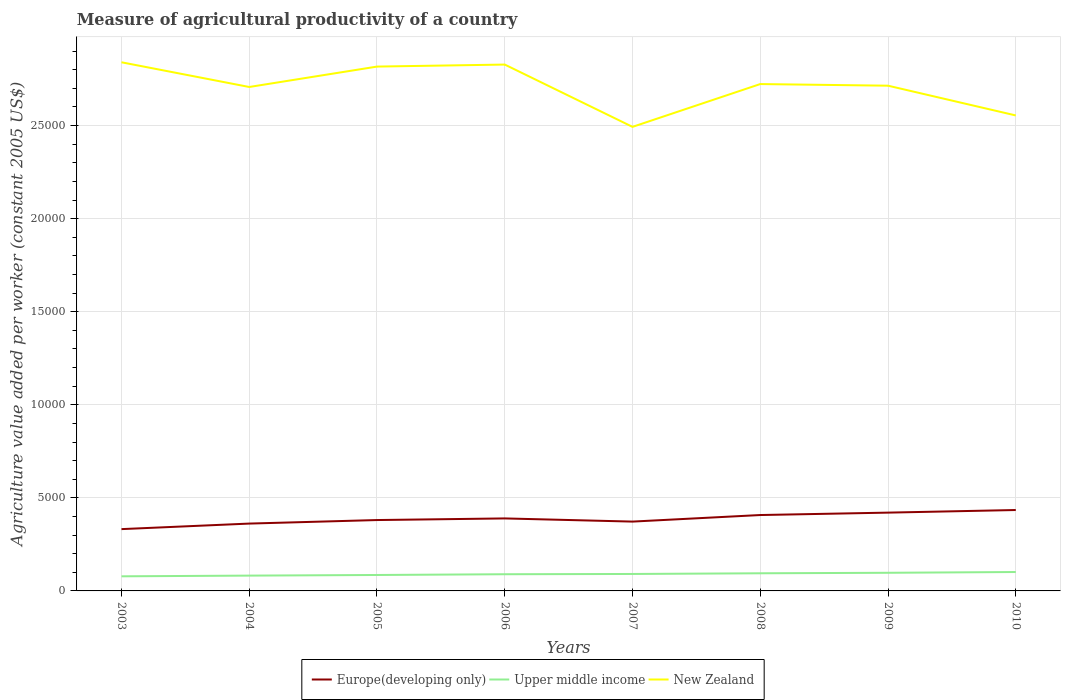How many different coloured lines are there?
Your response must be concise. 3. Across all years, what is the maximum measure of agricultural productivity in Europe(developing only)?
Your response must be concise. 3320.13. What is the total measure of agricultural productivity in New Zealand in the graph?
Give a very brief answer. -1096.03. What is the difference between the highest and the second highest measure of agricultural productivity in Upper middle income?
Your answer should be compact. 231.13. Is the measure of agricultural productivity in New Zealand strictly greater than the measure of agricultural productivity in Upper middle income over the years?
Make the answer very short. No. How many years are there in the graph?
Ensure brevity in your answer.  8. What is the difference between two consecutive major ticks on the Y-axis?
Make the answer very short. 5000. What is the title of the graph?
Ensure brevity in your answer.  Measure of agricultural productivity of a country. Does "Gabon" appear as one of the legend labels in the graph?
Provide a short and direct response. No. What is the label or title of the Y-axis?
Keep it short and to the point. Agriculture value added per worker (constant 2005 US$). What is the Agriculture value added per worker (constant 2005 US$) in Europe(developing only) in 2003?
Your answer should be very brief. 3320.13. What is the Agriculture value added per worker (constant 2005 US$) of Upper middle income in 2003?
Provide a short and direct response. 784.7. What is the Agriculture value added per worker (constant 2005 US$) in New Zealand in 2003?
Your answer should be compact. 2.84e+04. What is the Agriculture value added per worker (constant 2005 US$) of Europe(developing only) in 2004?
Provide a short and direct response. 3617.49. What is the Agriculture value added per worker (constant 2005 US$) of Upper middle income in 2004?
Your answer should be compact. 822.73. What is the Agriculture value added per worker (constant 2005 US$) of New Zealand in 2004?
Your answer should be compact. 2.71e+04. What is the Agriculture value added per worker (constant 2005 US$) of Europe(developing only) in 2005?
Keep it short and to the point. 3807.13. What is the Agriculture value added per worker (constant 2005 US$) in Upper middle income in 2005?
Offer a very short reply. 856.05. What is the Agriculture value added per worker (constant 2005 US$) in New Zealand in 2005?
Your answer should be very brief. 2.82e+04. What is the Agriculture value added per worker (constant 2005 US$) of Europe(developing only) in 2006?
Provide a succinct answer. 3894.52. What is the Agriculture value added per worker (constant 2005 US$) in Upper middle income in 2006?
Keep it short and to the point. 896.2. What is the Agriculture value added per worker (constant 2005 US$) of New Zealand in 2006?
Your answer should be compact. 2.83e+04. What is the Agriculture value added per worker (constant 2005 US$) in Europe(developing only) in 2007?
Give a very brief answer. 3724.44. What is the Agriculture value added per worker (constant 2005 US$) in Upper middle income in 2007?
Make the answer very short. 910.43. What is the Agriculture value added per worker (constant 2005 US$) in New Zealand in 2007?
Ensure brevity in your answer.  2.49e+04. What is the Agriculture value added per worker (constant 2005 US$) of Europe(developing only) in 2008?
Your answer should be compact. 4077.1. What is the Agriculture value added per worker (constant 2005 US$) of Upper middle income in 2008?
Offer a terse response. 947.85. What is the Agriculture value added per worker (constant 2005 US$) in New Zealand in 2008?
Give a very brief answer. 2.72e+04. What is the Agriculture value added per worker (constant 2005 US$) in Europe(developing only) in 2009?
Your response must be concise. 4205.82. What is the Agriculture value added per worker (constant 2005 US$) in Upper middle income in 2009?
Ensure brevity in your answer.  974.73. What is the Agriculture value added per worker (constant 2005 US$) of New Zealand in 2009?
Provide a short and direct response. 2.71e+04. What is the Agriculture value added per worker (constant 2005 US$) of Europe(developing only) in 2010?
Provide a short and direct response. 4346.2. What is the Agriculture value added per worker (constant 2005 US$) in Upper middle income in 2010?
Your response must be concise. 1015.83. What is the Agriculture value added per worker (constant 2005 US$) in New Zealand in 2010?
Offer a terse response. 2.55e+04. Across all years, what is the maximum Agriculture value added per worker (constant 2005 US$) in Europe(developing only)?
Provide a succinct answer. 4346.2. Across all years, what is the maximum Agriculture value added per worker (constant 2005 US$) in Upper middle income?
Offer a very short reply. 1015.83. Across all years, what is the maximum Agriculture value added per worker (constant 2005 US$) of New Zealand?
Your answer should be compact. 2.84e+04. Across all years, what is the minimum Agriculture value added per worker (constant 2005 US$) of Europe(developing only)?
Provide a succinct answer. 3320.13. Across all years, what is the minimum Agriculture value added per worker (constant 2005 US$) of Upper middle income?
Keep it short and to the point. 784.7. Across all years, what is the minimum Agriculture value added per worker (constant 2005 US$) in New Zealand?
Give a very brief answer. 2.49e+04. What is the total Agriculture value added per worker (constant 2005 US$) of Europe(developing only) in the graph?
Give a very brief answer. 3.10e+04. What is the total Agriculture value added per worker (constant 2005 US$) in Upper middle income in the graph?
Make the answer very short. 7208.51. What is the total Agriculture value added per worker (constant 2005 US$) of New Zealand in the graph?
Give a very brief answer. 2.17e+05. What is the difference between the Agriculture value added per worker (constant 2005 US$) of Europe(developing only) in 2003 and that in 2004?
Offer a very short reply. -297.36. What is the difference between the Agriculture value added per worker (constant 2005 US$) of Upper middle income in 2003 and that in 2004?
Your response must be concise. -38.03. What is the difference between the Agriculture value added per worker (constant 2005 US$) of New Zealand in 2003 and that in 2004?
Give a very brief answer. 1327.48. What is the difference between the Agriculture value added per worker (constant 2005 US$) of Europe(developing only) in 2003 and that in 2005?
Give a very brief answer. -487. What is the difference between the Agriculture value added per worker (constant 2005 US$) in Upper middle income in 2003 and that in 2005?
Your answer should be very brief. -71.35. What is the difference between the Agriculture value added per worker (constant 2005 US$) of New Zealand in 2003 and that in 2005?
Give a very brief answer. 231.46. What is the difference between the Agriculture value added per worker (constant 2005 US$) of Europe(developing only) in 2003 and that in 2006?
Ensure brevity in your answer.  -574.4. What is the difference between the Agriculture value added per worker (constant 2005 US$) of Upper middle income in 2003 and that in 2006?
Offer a very short reply. -111.5. What is the difference between the Agriculture value added per worker (constant 2005 US$) in New Zealand in 2003 and that in 2006?
Offer a very short reply. 122.47. What is the difference between the Agriculture value added per worker (constant 2005 US$) in Europe(developing only) in 2003 and that in 2007?
Provide a succinct answer. -404.32. What is the difference between the Agriculture value added per worker (constant 2005 US$) in Upper middle income in 2003 and that in 2007?
Your response must be concise. -125.72. What is the difference between the Agriculture value added per worker (constant 2005 US$) in New Zealand in 2003 and that in 2007?
Your response must be concise. 3469.67. What is the difference between the Agriculture value added per worker (constant 2005 US$) of Europe(developing only) in 2003 and that in 2008?
Ensure brevity in your answer.  -756.97. What is the difference between the Agriculture value added per worker (constant 2005 US$) in Upper middle income in 2003 and that in 2008?
Offer a terse response. -163.15. What is the difference between the Agriculture value added per worker (constant 2005 US$) of New Zealand in 2003 and that in 2008?
Offer a terse response. 1169.99. What is the difference between the Agriculture value added per worker (constant 2005 US$) in Europe(developing only) in 2003 and that in 2009?
Ensure brevity in your answer.  -885.69. What is the difference between the Agriculture value added per worker (constant 2005 US$) in Upper middle income in 2003 and that in 2009?
Provide a short and direct response. -190.02. What is the difference between the Agriculture value added per worker (constant 2005 US$) in New Zealand in 2003 and that in 2009?
Keep it short and to the point. 1257.55. What is the difference between the Agriculture value added per worker (constant 2005 US$) in Europe(developing only) in 2003 and that in 2010?
Your answer should be very brief. -1026.08. What is the difference between the Agriculture value added per worker (constant 2005 US$) of Upper middle income in 2003 and that in 2010?
Ensure brevity in your answer.  -231.13. What is the difference between the Agriculture value added per worker (constant 2005 US$) of New Zealand in 2003 and that in 2010?
Your response must be concise. 2855.97. What is the difference between the Agriculture value added per worker (constant 2005 US$) of Europe(developing only) in 2004 and that in 2005?
Your response must be concise. -189.64. What is the difference between the Agriculture value added per worker (constant 2005 US$) of Upper middle income in 2004 and that in 2005?
Make the answer very short. -33.32. What is the difference between the Agriculture value added per worker (constant 2005 US$) in New Zealand in 2004 and that in 2005?
Provide a short and direct response. -1096.03. What is the difference between the Agriculture value added per worker (constant 2005 US$) of Europe(developing only) in 2004 and that in 2006?
Offer a very short reply. -277.04. What is the difference between the Agriculture value added per worker (constant 2005 US$) in Upper middle income in 2004 and that in 2006?
Your answer should be compact. -73.46. What is the difference between the Agriculture value added per worker (constant 2005 US$) in New Zealand in 2004 and that in 2006?
Make the answer very short. -1205.01. What is the difference between the Agriculture value added per worker (constant 2005 US$) of Europe(developing only) in 2004 and that in 2007?
Provide a short and direct response. -106.96. What is the difference between the Agriculture value added per worker (constant 2005 US$) in Upper middle income in 2004 and that in 2007?
Make the answer very short. -87.69. What is the difference between the Agriculture value added per worker (constant 2005 US$) in New Zealand in 2004 and that in 2007?
Keep it short and to the point. 2142.19. What is the difference between the Agriculture value added per worker (constant 2005 US$) in Europe(developing only) in 2004 and that in 2008?
Provide a succinct answer. -459.61. What is the difference between the Agriculture value added per worker (constant 2005 US$) of Upper middle income in 2004 and that in 2008?
Your answer should be compact. -125.12. What is the difference between the Agriculture value added per worker (constant 2005 US$) of New Zealand in 2004 and that in 2008?
Offer a very short reply. -157.49. What is the difference between the Agriculture value added per worker (constant 2005 US$) of Europe(developing only) in 2004 and that in 2009?
Ensure brevity in your answer.  -588.33. What is the difference between the Agriculture value added per worker (constant 2005 US$) of Upper middle income in 2004 and that in 2009?
Give a very brief answer. -151.99. What is the difference between the Agriculture value added per worker (constant 2005 US$) in New Zealand in 2004 and that in 2009?
Your answer should be compact. -69.94. What is the difference between the Agriculture value added per worker (constant 2005 US$) of Europe(developing only) in 2004 and that in 2010?
Your answer should be very brief. -728.72. What is the difference between the Agriculture value added per worker (constant 2005 US$) of Upper middle income in 2004 and that in 2010?
Keep it short and to the point. -193.09. What is the difference between the Agriculture value added per worker (constant 2005 US$) in New Zealand in 2004 and that in 2010?
Your answer should be very brief. 1528.49. What is the difference between the Agriculture value added per worker (constant 2005 US$) of Europe(developing only) in 2005 and that in 2006?
Make the answer very short. -87.4. What is the difference between the Agriculture value added per worker (constant 2005 US$) of Upper middle income in 2005 and that in 2006?
Provide a short and direct response. -40.15. What is the difference between the Agriculture value added per worker (constant 2005 US$) of New Zealand in 2005 and that in 2006?
Make the answer very short. -108.99. What is the difference between the Agriculture value added per worker (constant 2005 US$) of Europe(developing only) in 2005 and that in 2007?
Offer a very short reply. 82.68. What is the difference between the Agriculture value added per worker (constant 2005 US$) in Upper middle income in 2005 and that in 2007?
Give a very brief answer. -54.38. What is the difference between the Agriculture value added per worker (constant 2005 US$) of New Zealand in 2005 and that in 2007?
Your answer should be compact. 3238.21. What is the difference between the Agriculture value added per worker (constant 2005 US$) in Europe(developing only) in 2005 and that in 2008?
Keep it short and to the point. -269.97. What is the difference between the Agriculture value added per worker (constant 2005 US$) of Upper middle income in 2005 and that in 2008?
Provide a succinct answer. -91.8. What is the difference between the Agriculture value added per worker (constant 2005 US$) in New Zealand in 2005 and that in 2008?
Your answer should be compact. 938.53. What is the difference between the Agriculture value added per worker (constant 2005 US$) of Europe(developing only) in 2005 and that in 2009?
Your answer should be compact. -398.69. What is the difference between the Agriculture value added per worker (constant 2005 US$) in Upper middle income in 2005 and that in 2009?
Your response must be concise. -118.68. What is the difference between the Agriculture value added per worker (constant 2005 US$) of New Zealand in 2005 and that in 2009?
Your answer should be compact. 1026.09. What is the difference between the Agriculture value added per worker (constant 2005 US$) in Europe(developing only) in 2005 and that in 2010?
Ensure brevity in your answer.  -539.08. What is the difference between the Agriculture value added per worker (constant 2005 US$) of Upper middle income in 2005 and that in 2010?
Keep it short and to the point. -159.78. What is the difference between the Agriculture value added per worker (constant 2005 US$) of New Zealand in 2005 and that in 2010?
Give a very brief answer. 2624.51. What is the difference between the Agriculture value added per worker (constant 2005 US$) of Europe(developing only) in 2006 and that in 2007?
Offer a terse response. 170.08. What is the difference between the Agriculture value added per worker (constant 2005 US$) in Upper middle income in 2006 and that in 2007?
Ensure brevity in your answer.  -14.23. What is the difference between the Agriculture value added per worker (constant 2005 US$) in New Zealand in 2006 and that in 2007?
Offer a very short reply. 3347.2. What is the difference between the Agriculture value added per worker (constant 2005 US$) of Europe(developing only) in 2006 and that in 2008?
Offer a terse response. -182.58. What is the difference between the Agriculture value added per worker (constant 2005 US$) of Upper middle income in 2006 and that in 2008?
Keep it short and to the point. -51.65. What is the difference between the Agriculture value added per worker (constant 2005 US$) in New Zealand in 2006 and that in 2008?
Provide a short and direct response. 1047.52. What is the difference between the Agriculture value added per worker (constant 2005 US$) in Europe(developing only) in 2006 and that in 2009?
Provide a succinct answer. -311.29. What is the difference between the Agriculture value added per worker (constant 2005 US$) in Upper middle income in 2006 and that in 2009?
Your response must be concise. -78.53. What is the difference between the Agriculture value added per worker (constant 2005 US$) of New Zealand in 2006 and that in 2009?
Your answer should be compact. 1135.08. What is the difference between the Agriculture value added per worker (constant 2005 US$) of Europe(developing only) in 2006 and that in 2010?
Offer a very short reply. -451.68. What is the difference between the Agriculture value added per worker (constant 2005 US$) of Upper middle income in 2006 and that in 2010?
Your answer should be compact. -119.63. What is the difference between the Agriculture value added per worker (constant 2005 US$) of New Zealand in 2006 and that in 2010?
Keep it short and to the point. 2733.5. What is the difference between the Agriculture value added per worker (constant 2005 US$) of Europe(developing only) in 2007 and that in 2008?
Keep it short and to the point. -352.66. What is the difference between the Agriculture value added per worker (constant 2005 US$) in Upper middle income in 2007 and that in 2008?
Your answer should be very brief. -37.42. What is the difference between the Agriculture value added per worker (constant 2005 US$) of New Zealand in 2007 and that in 2008?
Provide a short and direct response. -2299.68. What is the difference between the Agriculture value added per worker (constant 2005 US$) in Europe(developing only) in 2007 and that in 2009?
Give a very brief answer. -481.37. What is the difference between the Agriculture value added per worker (constant 2005 US$) in Upper middle income in 2007 and that in 2009?
Keep it short and to the point. -64.3. What is the difference between the Agriculture value added per worker (constant 2005 US$) in New Zealand in 2007 and that in 2009?
Your answer should be very brief. -2212.12. What is the difference between the Agriculture value added per worker (constant 2005 US$) of Europe(developing only) in 2007 and that in 2010?
Ensure brevity in your answer.  -621.76. What is the difference between the Agriculture value added per worker (constant 2005 US$) of Upper middle income in 2007 and that in 2010?
Offer a very short reply. -105.4. What is the difference between the Agriculture value added per worker (constant 2005 US$) of New Zealand in 2007 and that in 2010?
Your response must be concise. -613.7. What is the difference between the Agriculture value added per worker (constant 2005 US$) of Europe(developing only) in 2008 and that in 2009?
Provide a short and direct response. -128.72. What is the difference between the Agriculture value added per worker (constant 2005 US$) of Upper middle income in 2008 and that in 2009?
Provide a succinct answer. -26.88. What is the difference between the Agriculture value added per worker (constant 2005 US$) of New Zealand in 2008 and that in 2009?
Your answer should be compact. 87.55. What is the difference between the Agriculture value added per worker (constant 2005 US$) in Europe(developing only) in 2008 and that in 2010?
Keep it short and to the point. -269.1. What is the difference between the Agriculture value added per worker (constant 2005 US$) of Upper middle income in 2008 and that in 2010?
Your response must be concise. -67.98. What is the difference between the Agriculture value added per worker (constant 2005 US$) of New Zealand in 2008 and that in 2010?
Your answer should be compact. 1685.98. What is the difference between the Agriculture value added per worker (constant 2005 US$) in Europe(developing only) in 2009 and that in 2010?
Make the answer very short. -140.39. What is the difference between the Agriculture value added per worker (constant 2005 US$) in Upper middle income in 2009 and that in 2010?
Provide a short and direct response. -41.1. What is the difference between the Agriculture value added per worker (constant 2005 US$) in New Zealand in 2009 and that in 2010?
Provide a short and direct response. 1598.42. What is the difference between the Agriculture value added per worker (constant 2005 US$) in Europe(developing only) in 2003 and the Agriculture value added per worker (constant 2005 US$) in Upper middle income in 2004?
Make the answer very short. 2497.4. What is the difference between the Agriculture value added per worker (constant 2005 US$) of Europe(developing only) in 2003 and the Agriculture value added per worker (constant 2005 US$) of New Zealand in 2004?
Provide a succinct answer. -2.38e+04. What is the difference between the Agriculture value added per worker (constant 2005 US$) in Upper middle income in 2003 and the Agriculture value added per worker (constant 2005 US$) in New Zealand in 2004?
Offer a very short reply. -2.63e+04. What is the difference between the Agriculture value added per worker (constant 2005 US$) of Europe(developing only) in 2003 and the Agriculture value added per worker (constant 2005 US$) of Upper middle income in 2005?
Your answer should be very brief. 2464.08. What is the difference between the Agriculture value added per worker (constant 2005 US$) in Europe(developing only) in 2003 and the Agriculture value added per worker (constant 2005 US$) in New Zealand in 2005?
Give a very brief answer. -2.48e+04. What is the difference between the Agriculture value added per worker (constant 2005 US$) of Upper middle income in 2003 and the Agriculture value added per worker (constant 2005 US$) of New Zealand in 2005?
Give a very brief answer. -2.74e+04. What is the difference between the Agriculture value added per worker (constant 2005 US$) of Europe(developing only) in 2003 and the Agriculture value added per worker (constant 2005 US$) of Upper middle income in 2006?
Provide a short and direct response. 2423.93. What is the difference between the Agriculture value added per worker (constant 2005 US$) of Europe(developing only) in 2003 and the Agriculture value added per worker (constant 2005 US$) of New Zealand in 2006?
Give a very brief answer. -2.50e+04. What is the difference between the Agriculture value added per worker (constant 2005 US$) in Upper middle income in 2003 and the Agriculture value added per worker (constant 2005 US$) in New Zealand in 2006?
Offer a very short reply. -2.75e+04. What is the difference between the Agriculture value added per worker (constant 2005 US$) in Europe(developing only) in 2003 and the Agriculture value added per worker (constant 2005 US$) in Upper middle income in 2007?
Keep it short and to the point. 2409.7. What is the difference between the Agriculture value added per worker (constant 2005 US$) in Europe(developing only) in 2003 and the Agriculture value added per worker (constant 2005 US$) in New Zealand in 2007?
Your answer should be compact. -2.16e+04. What is the difference between the Agriculture value added per worker (constant 2005 US$) of Upper middle income in 2003 and the Agriculture value added per worker (constant 2005 US$) of New Zealand in 2007?
Ensure brevity in your answer.  -2.41e+04. What is the difference between the Agriculture value added per worker (constant 2005 US$) of Europe(developing only) in 2003 and the Agriculture value added per worker (constant 2005 US$) of Upper middle income in 2008?
Your response must be concise. 2372.28. What is the difference between the Agriculture value added per worker (constant 2005 US$) of Europe(developing only) in 2003 and the Agriculture value added per worker (constant 2005 US$) of New Zealand in 2008?
Make the answer very short. -2.39e+04. What is the difference between the Agriculture value added per worker (constant 2005 US$) in Upper middle income in 2003 and the Agriculture value added per worker (constant 2005 US$) in New Zealand in 2008?
Your answer should be compact. -2.64e+04. What is the difference between the Agriculture value added per worker (constant 2005 US$) in Europe(developing only) in 2003 and the Agriculture value added per worker (constant 2005 US$) in Upper middle income in 2009?
Provide a succinct answer. 2345.4. What is the difference between the Agriculture value added per worker (constant 2005 US$) in Europe(developing only) in 2003 and the Agriculture value added per worker (constant 2005 US$) in New Zealand in 2009?
Your answer should be compact. -2.38e+04. What is the difference between the Agriculture value added per worker (constant 2005 US$) of Upper middle income in 2003 and the Agriculture value added per worker (constant 2005 US$) of New Zealand in 2009?
Provide a short and direct response. -2.64e+04. What is the difference between the Agriculture value added per worker (constant 2005 US$) in Europe(developing only) in 2003 and the Agriculture value added per worker (constant 2005 US$) in Upper middle income in 2010?
Keep it short and to the point. 2304.3. What is the difference between the Agriculture value added per worker (constant 2005 US$) of Europe(developing only) in 2003 and the Agriculture value added per worker (constant 2005 US$) of New Zealand in 2010?
Your response must be concise. -2.22e+04. What is the difference between the Agriculture value added per worker (constant 2005 US$) in Upper middle income in 2003 and the Agriculture value added per worker (constant 2005 US$) in New Zealand in 2010?
Keep it short and to the point. -2.48e+04. What is the difference between the Agriculture value added per worker (constant 2005 US$) of Europe(developing only) in 2004 and the Agriculture value added per worker (constant 2005 US$) of Upper middle income in 2005?
Provide a short and direct response. 2761.44. What is the difference between the Agriculture value added per worker (constant 2005 US$) of Europe(developing only) in 2004 and the Agriculture value added per worker (constant 2005 US$) of New Zealand in 2005?
Ensure brevity in your answer.  -2.45e+04. What is the difference between the Agriculture value added per worker (constant 2005 US$) of Upper middle income in 2004 and the Agriculture value added per worker (constant 2005 US$) of New Zealand in 2005?
Offer a terse response. -2.73e+04. What is the difference between the Agriculture value added per worker (constant 2005 US$) in Europe(developing only) in 2004 and the Agriculture value added per worker (constant 2005 US$) in Upper middle income in 2006?
Keep it short and to the point. 2721.29. What is the difference between the Agriculture value added per worker (constant 2005 US$) of Europe(developing only) in 2004 and the Agriculture value added per worker (constant 2005 US$) of New Zealand in 2006?
Your response must be concise. -2.47e+04. What is the difference between the Agriculture value added per worker (constant 2005 US$) in Upper middle income in 2004 and the Agriculture value added per worker (constant 2005 US$) in New Zealand in 2006?
Offer a terse response. -2.75e+04. What is the difference between the Agriculture value added per worker (constant 2005 US$) of Europe(developing only) in 2004 and the Agriculture value added per worker (constant 2005 US$) of Upper middle income in 2007?
Your response must be concise. 2707.06. What is the difference between the Agriculture value added per worker (constant 2005 US$) in Europe(developing only) in 2004 and the Agriculture value added per worker (constant 2005 US$) in New Zealand in 2007?
Give a very brief answer. -2.13e+04. What is the difference between the Agriculture value added per worker (constant 2005 US$) in Upper middle income in 2004 and the Agriculture value added per worker (constant 2005 US$) in New Zealand in 2007?
Your response must be concise. -2.41e+04. What is the difference between the Agriculture value added per worker (constant 2005 US$) in Europe(developing only) in 2004 and the Agriculture value added per worker (constant 2005 US$) in Upper middle income in 2008?
Make the answer very short. 2669.64. What is the difference between the Agriculture value added per worker (constant 2005 US$) of Europe(developing only) in 2004 and the Agriculture value added per worker (constant 2005 US$) of New Zealand in 2008?
Offer a terse response. -2.36e+04. What is the difference between the Agriculture value added per worker (constant 2005 US$) in Upper middle income in 2004 and the Agriculture value added per worker (constant 2005 US$) in New Zealand in 2008?
Your answer should be compact. -2.64e+04. What is the difference between the Agriculture value added per worker (constant 2005 US$) of Europe(developing only) in 2004 and the Agriculture value added per worker (constant 2005 US$) of Upper middle income in 2009?
Give a very brief answer. 2642.76. What is the difference between the Agriculture value added per worker (constant 2005 US$) of Europe(developing only) in 2004 and the Agriculture value added per worker (constant 2005 US$) of New Zealand in 2009?
Your answer should be very brief. -2.35e+04. What is the difference between the Agriculture value added per worker (constant 2005 US$) in Upper middle income in 2004 and the Agriculture value added per worker (constant 2005 US$) in New Zealand in 2009?
Your response must be concise. -2.63e+04. What is the difference between the Agriculture value added per worker (constant 2005 US$) of Europe(developing only) in 2004 and the Agriculture value added per worker (constant 2005 US$) of Upper middle income in 2010?
Offer a very short reply. 2601.66. What is the difference between the Agriculture value added per worker (constant 2005 US$) in Europe(developing only) in 2004 and the Agriculture value added per worker (constant 2005 US$) in New Zealand in 2010?
Provide a succinct answer. -2.19e+04. What is the difference between the Agriculture value added per worker (constant 2005 US$) of Upper middle income in 2004 and the Agriculture value added per worker (constant 2005 US$) of New Zealand in 2010?
Make the answer very short. -2.47e+04. What is the difference between the Agriculture value added per worker (constant 2005 US$) of Europe(developing only) in 2005 and the Agriculture value added per worker (constant 2005 US$) of Upper middle income in 2006?
Provide a short and direct response. 2910.93. What is the difference between the Agriculture value added per worker (constant 2005 US$) of Europe(developing only) in 2005 and the Agriculture value added per worker (constant 2005 US$) of New Zealand in 2006?
Offer a very short reply. -2.45e+04. What is the difference between the Agriculture value added per worker (constant 2005 US$) of Upper middle income in 2005 and the Agriculture value added per worker (constant 2005 US$) of New Zealand in 2006?
Keep it short and to the point. -2.74e+04. What is the difference between the Agriculture value added per worker (constant 2005 US$) of Europe(developing only) in 2005 and the Agriculture value added per worker (constant 2005 US$) of Upper middle income in 2007?
Your answer should be very brief. 2896.7. What is the difference between the Agriculture value added per worker (constant 2005 US$) of Europe(developing only) in 2005 and the Agriculture value added per worker (constant 2005 US$) of New Zealand in 2007?
Your answer should be very brief. -2.11e+04. What is the difference between the Agriculture value added per worker (constant 2005 US$) of Upper middle income in 2005 and the Agriculture value added per worker (constant 2005 US$) of New Zealand in 2007?
Keep it short and to the point. -2.41e+04. What is the difference between the Agriculture value added per worker (constant 2005 US$) in Europe(developing only) in 2005 and the Agriculture value added per worker (constant 2005 US$) in Upper middle income in 2008?
Provide a short and direct response. 2859.28. What is the difference between the Agriculture value added per worker (constant 2005 US$) of Europe(developing only) in 2005 and the Agriculture value added per worker (constant 2005 US$) of New Zealand in 2008?
Give a very brief answer. -2.34e+04. What is the difference between the Agriculture value added per worker (constant 2005 US$) in Upper middle income in 2005 and the Agriculture value added per worker (constant 2005 US$) in New Zealand in 2008?
Your answer should be compact. -2.64e+04. What is the difference between the Agriculture value added per worker (constant 2005 US$) of Europe(developing only) in 2005 and the Agriculture value added per worker (constant 2005 US$) of Upper middle income in 2009?
Give a very brief answer. 2832.4. What is the difference between the Agriculture value added per worker (constant 2005 US$) in Europe(developing only) in 2005 and the Agriculture value added per worker (constant 2005 US$) in New Zealand in 2009?
Give a very brief answer. -2.33e+04. What is the difference between the Agriculture value added per worker (constant 2005 US$) in Upper middle income in 2005 and the Agriculture value added per worker (constant 2005 US$) in New Zealand in 2009?
Offer a terse response. -2.63e+04. What is the difference between the Agriculture value added per worker (constant 2005 US$) in Europe(developing only) in 2005 and the Agriculture value added per worker (constant 2005 US$) in Upper middle income in 2010?
Offer a very short reply. 2791.3. What is the difference between the Agriculture value added per worker (constant 2005 US$) of Europe(developing only) in 2005 and the Agriculture value added per worker (constant 2005 US$) of New Zealand in 2010?
Provide a short and direct response. -2.17e+04. What is the difference between the Agriculture value added per worker (constant 2005 US$) in Upper middle income in 2005 and the Agriculture value added per worker (constant 2005 US$) in New Zealand in 2010?
Give a very brief answer. -2.47e+04. What is the difference between the Agriculture value added per worker (constant 2005 US$) of Europe(developing only) in 2006 and the Agriculture value added per worker (constant 2005 US$) of Upper middle income in 2007?
Give a very brief answer. 2984.1. What is the difference between the Agriculture value added per worker (constant 2005 US$) of Europe(developing only) in 2006 and the Agriculture value added per worker (constant 2005 US$) of New Zealand in 2007?
Make the answer very short. -2.10e+04. What is the difference between the Agriculture value added per worker (constant 2005 US$) of Upper middle income in 2006 and the Agriculture value added per worker (constant 2005 US$) of New Zealand in 2007?
Make the answer very short. -2.40e+04. What is the difference between the Agriculture value added per worker (constant 2005 US$) in Europe(developing only) in 2006 and the Agriculture value added per worker (constant 2005 US$) in Upper middle income in 2008?
Your answer should be very brief. 2946.68. What is the difference between the Agriculture value added per worker (constant 2005 US$) in Europe(developing only) in 2006 and the Agriculture value added per worker (constant 2005 US$) in New Zealand in 2008?
Your response must be concise. -2.33e+04. What is the difference between the Agriculture value added per worker (constant 2005 US$) of Upper middle income in 2006 and the Agriculture value added per worker (constant 2005 US$) of New Zealand in 2008?
Your answer should be very brief. -2.63e+04. What is the difference between the Agriculture value added per worker (constant 2005 US$) in Europe(developing only) in 2006 and the Agriculture value added per worker (constant 2005 US$) in Upper middle income in 2009?
Provide a succinct answer. 2919.8. What is the difference between the Agriculture value added per worker (constant 2005 US$) in Europe(developing only) in 2006 and the Agriculture value added per worker (constant 2005 US$) in New Zealand in 2009?
Offer a terse response. -2.32e+04. What is the difference between the Agriculture value added per worker (constant 2005 US$) in Upper middle income in 2006 and the Agriculture value added per worker (constant 2005 US$) in New Zealand in 2009?
Ensure brevity in your answer.  -2.62e+04. What is the difference between the Agriculture value added per worker (constant 2005 US$) of Europe(developing only) in 2006 and the Agriculture value added per worker (constant 2005 US$) of Upper middle income in 2010?
Your response must be concise. 2878.7. What is the difference between the Agriculture value added per worker (constant 2005 US$) of Europe(developing only) in 2006 and the Agriculture value added per worker (constant 2005 US$) of New Zealand in 2010?
Keep it short and to the point. -2.16e+04. What is the difference between the Agriculture value added per worker (constant 2005 US$) in Upper middle income in 2006 and the Agriculture value added per worker (constant 2005 US$) in New Zealand in 2010?
Your answer should be very brief. -2.46e+04. What is the difference between the Agriculture value added per worker (constant 2005 US$) in Europe(developing only) in 2007 and the Agriculture value added per worker (constant 2005 US$) in Upper middle income in 2008?
Offer a very short reply. 2776.6. What is the difference between the Agriculture value added per worker (constant 2005 US$) in Europe(developing only) in 2007 and the Agriculture value added per worker (constant 2005 US$) in New Zealand in 2008?
Your answer should be compact. -2.35e+04. What is the difference between the Agriculture value added per worker (constant 2005 US$) in Upper middle income in 2007 and the Agriculture value added per worker (constant 2005 US$) in New Zealand in 2008?
Give a very brief answer. -2.63e+04. What is the difference between the Agriculture value added per worker (constant 2005 US$) of Europe(developing only) in 2007 and the Agriculture value added per worker (constant 2005 US$) of Upper middle income in 2009?
Give a very brief answer. 2749.72. What is the difference between the Agriculture value added per worker (constant 2005 US$) in Europe(developing only) in 2007 and the Agriculture value added per worker (constant 2005 US$) in New Zealand in 2009?
Offer a very short reply. -2.34e+04. What is the difference between the Agriculture value added per worker (constant 2005 US$) in Upper middle income in 2007 and the Agriculture value added per worker (constant 2005 US$) in New Zealand in 2009?
Provide a short and direct response. -2.62e+04. What is the difference between the Agriculture value added per worker (constant 2005 US$) in Europe(developing only) in 2007 and the Agriculture value added per worker (constant 2005 US$) in Upper middle income in 2010?
Keep it short and to the point. 2708.62. What is the difference between the Agriculture value added per worker (constant 2005 US$) in Europe(developing only) in 2007 and the Agriculture value added per worker (constant 2005 US$) in New Zealand in 2010?
Offer a terse response. -2.18e+04. What is the difference between the Agriculture value added per worker (constant 2005 US$) in Upper middle income in 2007 and the Agriculture value added per worker (constant 2005 US$) in New Zealand in 2010?
Provide a short and direct response. -2.46e+04. What is the difference between the Agriculture value added per worker (constant 2005 US$) of Europe(developing only) in 2008 and the Agriculture value added per worker (constant 2005 US$) of Upper middle income in 2009?
Keep it short and to the point. 3102.37. What is the difference between the Agriculture value added per worker (constant 2005 US$) of Europe(developing only) in 2008 and the Agriculture value added per worker (constant 2005 US$) of New Zealand in 2009?
Your answer should be compact. -2.31e+04. What is the difference between the Agriculture value added per worker (constant 2005 US$) of Upper middle income in 2008 and the Agriculture value added per worker (constant 2005 US$) of New Zealand in 2009?
Offer a terse response. -2.62e+04. What is the difference between the Agriculture value added per worker (constant 2005 US$) in Europe(developing only) in 2008 and the Agriculture value added per worker (constant 2005 US$) in Upper middle income in 2010?
Your answer should be compact. 3061.27. What is the difference between the Agriculture value added per worker (constant 2005 US$) of Europe(developing only) in 2008 and the Agriculture value added per worker (constant 2005 US$) of New Zealand in 2010?
Make the answer very short. -2.15e+04. What is the difference between the Agriculture value added per worker (constant 2005 US$) of Upper middle income in 2008 and the Agriculture value added per worker (constant 2005 US$) of New Zealand in 2010?
Make the answer very short. -2.46e+04. What is the difference between the Agriculture value added per worker (constant 2005 US$) of Europe(developing only) in 2009 and the Agriculture value added per worker (constant 2005 US$) of Upper middle income in 2010?
Make the answer very short. 3189.99. What is the difference between the Agriculture value added per worker (constant 2005 US$) of Europe(developing only) in 2009 and the Agriculture value added per worker (constant 2005 US$) of New Zealand in 2010?
Make the answer very short. -2.13e+04. What is the difference between the Agriculture value added per worker (constant 2005 US$) in Upper middle income in 2009 and the Agriculture value added per worker (constant 2005 US$) in New Zealand in 2010?
Your response must be concise. -2.46e+04. What is the average Agriculture value added per worker (constant 2005 US$) of Europe(developing only) per year?
Provide a short and direct response. 3874.1. What is the average Agriculture value added per worker (constant 2005 US$) of Upper middle income per year?
Provide a short and direct response. 901.06. What is the average Agriculture value added per worker (constant 2005 US$) of New Zealand per year?
Make the answer very short. 2.71e+04. In the year 2003, what is the difference between the Agriculture value added per worker (constant 2005 US$) in Europe(developing only) and Agriculture value added per worker (constant 2005 US$) in Upper middle income?
Make the answer very short. 2535.43. In the year 2003, what is the difference between the Agriculture value added per worker (constant 2005 US$) in Europe(developing only) and Agriculture value added per worker (constant 2005 US$) in New Zealand?
Provide a short and direct response. -2.51e+04. In the year 2003, what is the difference between the Agriculture value added per worker (constant 2005 US$) of Upper middle income and Agriculture value added per worker (constant 2005 US$) of New Zealand?
Your answer should be compact. -2.76e+04. In the year 2004, what is the difference between the Agriculture value added per worker (constant 2005 US$) of Europe(developing only) and Agriculture value added per worker (constant 2005 US$) of Upper middle income?
Keep it short and to the point. 2794.76. In the year 2004, what is the difference between the Agriculture value added per worker (constant 2005 US$) in Europe(developing only) and Agriculture value added per worker (constant 2005 US$) in New Zealand?
Provide a short and direct response. -2.35e+04. In the year 2004, what is the difference between the Agriculture value added per worker (constant 2005 US$) of Upper middle income and Agriculture value added per worker (constant 2005 US$) of New Zealand?
Your answer should be very brief. -2.62e+04. In the year 2005, what is the difference between the Agriculture value added per worker (constant 2005 US$) in Europe(developing only) and Agriculture value added per worker (constant 2005 US$) in Upper middle income?
Provide a short and direct response. 2951.08. In the year 2005, what is the difference between the Agriculture value added per worker (constant 2005 US$) of Europe(developing only) and Agriculture value added per worker (constant 2005 US$) of New Zealand?
Keep it short and to the point. -2.44e+04. In the year 2005, what is the difference between the Agriculture value added per worker (constant 2005 US$) of Upper middle income and Agriculture value added per worker (constant 2005 US$) of New Zealand?
Offer a very short reply. -2.73e+04. In the year 2006, what is the difference between the Agriculture value added per worker (constant 2005 US$) in Europe(developing only) and Agriculture value added per worker (constant 2005 US$) in Upper middle income?
Your answer should be very brief. 2998.33. In the year 2006, what is the difference between the Agriculture value added per worker (constant 2005 US$) in Europe(developing only) and Agriculture value added per worker (constant 2005 US$) in New Zealand?
Your answer should be compact. -2.44e+04. In the year 2006, what is the difference between the Agriculture value added per worker (constant 2005 US$) in Upper middle income and Agriculture value added per worker (constant 2005 US$) in New Zealand?
Your response must be concise. -2.74e+04. In the year 2007, what is the difference between the Agriculture value added per worker (constant 2005 US$) of Europe(developing only) and Agriculture value added per worker (constant 2005 US$) of Upper middle income?
Offer a terse response. 2814.02. In the year 2007, what is the difference between the Agriculture value added per worker (constant 2005 US$) of Europe(developing only) and Agriculture value added per worker (constant 2005 US$) of New Zealand?
Your answer should be compact. -2.12e+04. In the year 2007, what is the difference between the Agriculture value added per worker (constant 2005 US$) in Upper middle income and Agriculture value added per worker (constant 2005 US$) in New Zealand?
Offer a terse response. -2.40e+04. In the year 2008, what is the difference between the Agriculture value added per worker (constant 2005 US$) in Europe(developing only) and Agriculture value added per worker (constant 2005 US$) in Upper middle income?
Your answer should be compact. 3129.25. In the year 2008, what is the difference between the Agriculture value added per worker (constant 2005 US$) of Europe(developing only) and Agriculture value added per worker (constant 2005 US$) of New Zealand?
Your answer should be compact. -2.32e+04. In the year 2008, what is the difference between the Agriculture value added per worker (constant 2005 US$) in Upper middle income and Agriculture value added per worker (constant 2005 US$) in New Zealand?
Give a very brief answer. -2.63e+04. In the year 2009, what is the difference between the Agriculture value added per worker (constant 2005 US$) in Europe(developing only) and Agriculture value added per worker (constant 2005 US$) in Upper middle income?
Your answer should be very brief. 3231.09. In the year 2009, what is the difference between the Agriculture value added per worker (constant 2005 US$) of Europe(developing only) and Agriculture value added per worker (constant 2005 US$) of New Zealand?
Your answer should be compact. -2.29e+04. In the year 2009, what is the difference between the Agriculture value added per worker (constant 2005 US$) of Upper middle income and Agriculture value added per worker (constant 2005 US$) of New Zealand?
Provide a short and direct response. -2.62e+04. In the year 2010, what is the difference between the Agriculture value added per worker (constant 2005 US$) of Europe(developing only) and Agriculture value added per worker (constant 2005 US$) of Upper middle income?
Your answer should be compact. 3330.38. In the year 2010, what is the difference between the Agriculture value added per worker (constant 2005 US$) in Europe(developing only) and Agriculture value added per worker (constant 2005 US$) in New Zealand?
Give a very brief answer. -2.12e+04. In the year 2010, what is the difference between the Agriculture value added per worker (constant 2005 US$) of Upper middle income and Agriculture value added per worker (constant 2005 US$) of New Zealand?
Make the answer very short. -2.45e+04. What is the ratio of the Agriculture value added per worker (constant 2005 US$) in Europe(developing only) in 2003 to that in 2004?
Provide a short and direct response. 0.92. What is the ratio of the Agriculture value added per worker (constant 2005 US$) of Upper middle income in 2003 to that in 2004?
Offer a terse response. 0.95. What is the ratio of the Agriculture value added per worker (constant 2005 US$) of New Zealand in 2003 to that in 2004?
Your response must be concise. 1.05. What is the ratio of the Agriculture value added per worker (constant 2005 US$) in Europe(developing only) in 2003 to that in 2005?
Your answer should be compact. 0.87. What is the ratio of the Agriculture value added per worker (constant 2005 US$) in New Zealand in 2003 to that in 2005?
Keep it short and to the point. 1.01. What is the ratio of the Agriculture value added per worker (constant 2005 US$) in Europe(developing only) in 2003 to that in 2006?
Provide a short and direct response. 0.85. What is the ratio of the Agriculture value added per worker (constant 2005 US$) in Upper middle income in 2003 to that in 2006?
Your answer should be very brief. 0.88. What is the ratio of the Agriculture value added per worker (constant 2005 US$) of Europe(developing only) in 2003 to that in 2007?
Offer a very short reply. 0.89. What is the ratio of the Agriculture value added per worker (constant 2005 US$) of Upper middle income in 2003 to that in 2007?
Make the answer very short. 0.86. What is the ratio of the Agriculture value added per worker (constant 2005 US$) in New Zealand in 2003 to that in 2007?
Keep it short and to the point. 1.14. What is the ratio of the Agriculture value added per worker (constant 2005 US$) in Europe(developing only) in 2003 to that in 2008?
Your answer should be compact. 0.81. What is the ratio of the Agriculture value added per worker (constant 2005 US$) in Upper middle income in 2003 to that in 2008?
Provide a short and direct response. 0.83. What is the ratio of the Agriculture value added per worker (constant 2005 US$) of New Zealand in 2003 to that in 2008?
Ensure brevity in your answer.  1.04. What is the ratio of the Agriculture value added per worker (constant 2005 US$) of Europe(developing only) in 2003 to that in 2009?
Offer a very short reply. 0.79. What is the ratio of the Agriculture value added per worker (constant 2005 US$) of Upper middle income in 2003 to that in 2009?
Your response must be concise. 0.81. What is the ratio of the Agriculture value added per worker (constant 2005 US$) in New Zealand in 2003 to that in 2009?
Offer a terse response. 1.05. What is the ratio of the Agriculture value added per worker (constant 2005 US$) in Europe(developing only) in 2003 to that in 2010?
Ensure brevity in your answer.  0.76. What is the ratio of the Agriculture value added per worker (constant 2005 US$) of Upper middle income in 2003 to that in 2010?
Provide a succinct answer. 0.77. What is the ratio of the Agriculture value added per worker (constant 2005 US$) in New Zealand in 2003 to that in 2010?
Provide a short and direct response. 1.11. What is the ratio of the Agriculture value added per worker (constant 2005 US$) in Europe(developing only) in 2004 to that in 2005?
Your answer should be compact. 0.95. What is the ratio of the Agriculture value added per worker (constant 2005 US$) in Upper middle income in 2004 to that in 2005?
Give a very brief answer. 0.96. What is the ratio of the Agriculture value added per worker (constant 2005 US$) of New Zealand in 2004 to that in 2005?
Give a very brief answer. 0.96. What is the ratio of the Agriculture value added per worker (constant 2005 US$) of Europe(developing only) in 2004 to that in 2006?
Offer a terse response. 0.93. What is the ratio of the Agriculture value added per worker (constant 2005 US$) in Upper middle income in 2004 to that in 2006?
Offer a terse response. 0.92. What is the ratio of the Agriculture value added per worker (constant 2005 US$) of New Zealand in 2004 to that in 2006?
Provide a short and direct response. 0.96. What is the ratio of the Agriculture value added per worker (constant 2005 US$) in Europe(developing only) in 2004 to that in 2007?
Keep it short and to the point. 0.97. What is the ratio of the Agriculture value added per worker (constant 2005 US$) in Upper middle income in 2004 to that in 2007?
Offer a terse response. 0.9. What is the ratio of the Agriculture value added per worker (constant 2005 US$) in New Zealand in 2004 to that in 2007?
Ensure brevity in your answer.  1.09. What is the ratio of the Agriculture value added per worker (constant 2005 US$) of Europe(developing only) in 2004 to that in 2008?
Provide a succinct answer. 0.89. What is the ratio of the Agriculture value added per worker (constant 2005 US$) in Upper middle income in 2004 to that in 2008?
Provide a succinct answer. 0.87. What is the ratio of the Agriculture value added per worker (constant 2005 US$) in Europe(developing only) in 2004 to that in 2009?
Your response must be concise. 0.86. What is the ratio of the Agriculture value added per worker (constant 2005 US$) of Upper middle income in 2004 to that in 2009?
Your answer should be compact. 0.84. What is the ratio of the Agriculture value added per worker (constant 2005 US$) in New Zealand in 2004 to that in 2009?
Your answer should be compact. 1. What is the ratio of the Agriculture value added per worker (constant 2005 US$) of Europe(developing only) in 2004 to that in 2010?
Offer a very short reply. 0.83. What is the ratio of the Agriculture value added per worker (constant 2005 US$) in Upper middle income in 2004 to that in 2010?
Offer a terse response. 0.81. What is the ratio of the Agriculture value added per worker (constant 2005 US$) of New Zealand in 2004 to that in 2010?
Offer a very short reply. 1.06. What is the ratio of the Agriculture value added per worker (constant 2005 US$) of Europe(developing only) in 2005 to that in 2006?
Make the answer very short. 0.98. What is the ratio of the Agriculture value added per worker (constant 2005 US$) of Upper middle income in 2005 to that in 2006?
Your answer should be very brief. 0.96. What is the ratio of the Agriculture value added per worker (constant 2005 US$) of Europe(developing only) in 2005 to that in 2007?
Provide a short and direct response. 1.02. What is the ratio of the Agriculture value added per worker (constant 2005 US$) of Upper middle income in 2005 to that in 2007?
Your response must be concise. 0.94. What is the ratio of the Agriculture value added per worker (constant 2005 US$) of New Zealand in 2005 to that in 2007?
Your answer should be compact. 1.13. What is the ratio of the Agriculture value added per worker (constant 2005 US$) in Europe(developing only) in 2005 to that in 2008?
Provide a succinct answer. 0.93. What is the ratio of the Agriculture value added per worker (constant 2005 US$) in Upper middle income in 2005 to that in 2008?
Your answer should be compact. 0.9. What is the ratio of the Agriculture value added per worker (constant 2005 US$) of New Zealand in 2005 to that in 2008?
Offer a very short reply. 1.03. What is the ratio of the Agriculture value added per worker (constant 2005 US$) of Europe(developing only) in 2005 to that in 2009?
Your answer should be compact. 0.91. What is the ratio of the Agriculture value added per worker (constant 2005 US$) in Upper middle income in 2005 to that in 2009?
Provide a succinct answer. 0.88. What is the ratio of the Agriculture value added per worker (constant 2005 US$) in New Zealand in 2005 to that in 2009?
Your answer should be very brief. 1.04. What is the ratio of the Agriculture value added per worker (constant 2005 US$) of Europe(developing only) in 2005 to that in 2010?
Provide a succinct answer. 0.88. What is the ratio of the Agriculture value added per worker (constant 2005 US$) in Upper middle income in 2005 to that in 2010?
Offer a terse response. 0.84. What is the ratio of the Agriculture value added per worker (constant 2005 US$) in New Zealand in 2005 to that in 2010?
Offer a very short reply. 1.1. What is the ratio of the Agriculture value added per worker (constant 2005 US$) in Europe(developing only) in 2006 to that in 2007?
Make the answer very short. 1.05. What is the ratio of the Agriculture value added per worker (constant 2005 US$) in Upper middle income in 2006 to that in 2007?
Offer a very short reply. 0.98. What is the ratio of the Agriculture value added per worker (constant 2005 US$) of New Zealand in 2006 to that in 2007?
Provide a short and direct response. 1.13. What is the ratio of the Agriculture value added per worker (constant 2005 US$) in Europe(developing only) in 2006 to that in 2008?
Give a very brief answer. 0.96. What is the ratio of the Agriculture value added per worker (constant 2005 US$) of Upper middle income in 2006 to that in 2008?
Your answer should be compact. 0.95. What is the ratio of the Agriculture value added per worker (constant 2005 US$) in Europe(developing only) in 2006 to that in 2009?
Offer a very short reply. 0.93. What is the ratio of the Agriculture value added per worker (constant 2005 US$) in Upper middle income in 2006 to that in 2009?
Your response must be concise. 0.92. What is the ratio of the Agriculture value added per worker (constant 2005 US$) in New Zealand in 2006 to that in 2009?
Offer a terse response. 1.04. What is the ratio of the Agriculture value added per worker (constant 2005 US$) in Europe(developing only) in 2006 to that in 2010?
Provide a succinct answer. 0.9. What is the ratio of the Agriculture value added per worker (constant 2005 US$) in Upper middle income in 2006 to that in 2010?
Your response must be concise. 0.88. What is the ratio of the Agriculture value added per worker (constant 2005 US$) of New Zealand in 2006 to that in 2010?
Provide a short and direct response. 1.11. What is the ratio of the Agriculture value added per worker (constant 2005 US$) of Europe(developing only) in 2007 to that in 2008?
Give a very brief answer. 0.91. What is the ratio of the Agriculture value added per worker (constant 2005 US$) of Upper middle income in 2007 to that in 2008?
Offer a very short reply. 0.96. What is the ratio of the Agriculture value added per worker (constant 2005 US$) of New Zealand in 2007 to that in 2008?
Your answer should be very brief. 0.92. What is the ratio of the Agriculture value added per worker (constant 2005 US$) of Europe(developing only) in 2007 to that in 2009?
Your response must be concise. 0.89. What is the ratio of the Agriculture value added per worker (constant 2005 US$) in Upper middle income in 2007 to that in 2009?
Your answer should be very brief. 0.93. What is the ratio of the Agriculture value added per worker (constant 2005 US$) in New Zealand in 2007 to that in 2009?
Provide a succinct answer. 0.92. What is the ratio of the Agriculture value added per worker (constant 2005 US$) of Europe(developing only) in 2007 to that in 2010?
Provide a succinct answer. 0.86. What is the ratio of the Agriculture value added per worker (constant 2005 US$) of Upper middle income in 2007 to that in 2010?
Provide a succinct answer. 0.9. What is the ratio of the Agriculture value added per worker (constant 2005 US$) of New Zealand in 2007 to that in 2010?
Ensure brevity in your answer.  0.98. What is the ratio of the Agriculture value added per worker (constant 2005 US$) of Europe(developing only) in 2008 to that in 2009?
Offer a very short reply. 0.97. What is the ratio of the Agriculture value added per worker (constant 2005 US$) of Upper middle income in 2008 to that in 2009?
Offer a very short reply. 0.97. What is the ratio of the Agriculture value added per worker (constant 2005 US$) of New Zealand in 2008 to that in 2009?
Your answer should be compact. 1. What is the ratio of the Agriculture value added per worker (constant 2005 US$) of Europe(developing only) in 2008 to that in 2010?
Make the answer very short. 0.94. What is the ratio of the Agriculture value added per worker (constant 2005 US$) in Upper middle income in 2008 to that in 2010?
Offer a terse response. 0.93. What is the ratio of the Agriculture value added per worker (constant 2005 US$) of New Zealand in 2008 to that in 2010?
Offer a terse response. 1.07. What is the ratio of the Agriculture value added per worker (constant 2005 US$) of Europe(developing only) in 2009 to that in 2010?
Ensure brevity in your answer.  0.97. What is the ratio of the Agriculture value added per worker (constant 2005 US$) of Upper middle income in 2009 to that in 2010?
Your response must be concise. 0.96. What is the ratio of the Agriculture value added per worker (constant 2005 US$) of New Zealand in 2009 to that in 2010?
Your answer should be compact. 1.06. What is the difference between the highest and the second highest Agriculture value added per worker (constant 2005 US$) of Europe(developing only)?
Your response must be concise. 140.39. What is the difference between the highest and the second highest Agriculture value added per worker (constant 2005 US$) in Upper middle income?
Ensure brevity in your answer.  41.1. What is the difference between the highest and the second highest Agriculture value added per worker (constant 2005 US$) in New Zealand?
Ensure brevity in your answer.  122.47. What is the difference between the highest and the lowest Agriculture value added per worker (constant 2005 US$) in Europe(developing only)?
Your response must be concise. 1026.08. What is the difference between the highest and the lowest Agriculture value added per worker (constant 2005 US$) in Upper middle income?
Keep it short and to the point. 231.13. What is the difference between the highest and the lowest Agriculture value added per worker (constant 2005 US$) of New Zealand?
Ensure brevity in your answer.  3469.67. 